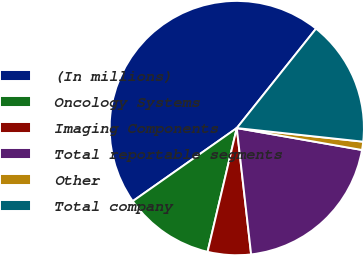Convert chart. <chart><loc_0><loc_0><loc_500><loc_500><pie_chart><fcel>(In millions)<fcel>Oncology Systems<fcel>Imaging Components<fcel>Total reportable segments<fcel>Other<fcel>Total company<nl><fcel>45.46%<fcel>11.56%<fcel>5.49%<fcel>20.44%<fcel>1.05%<fcel>16.0%<nl></chart> 